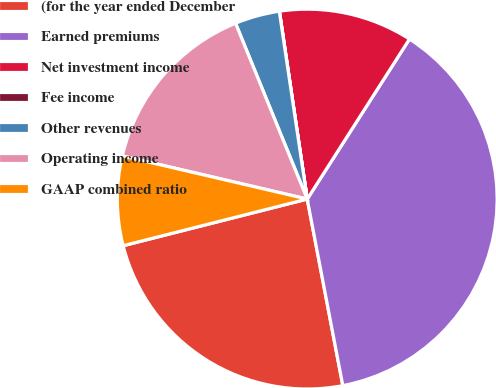<chart> <loc_0><loc_0><loc_500><loc_500><pie_chart><fcel>(for the year ended December<fcel>Earned premiums<fcel>Net investment income<fcel>Fee income<fcel>Other revenues<fcel>Operating income<fcel>GAAP combined ratio<nl><fcel>24.05%<fcel>37.95%<fcel>11.39%<fcel>0.01%<fcel>3.81%<fcel>15.19%<fcel>7.6%<nl></chart> 